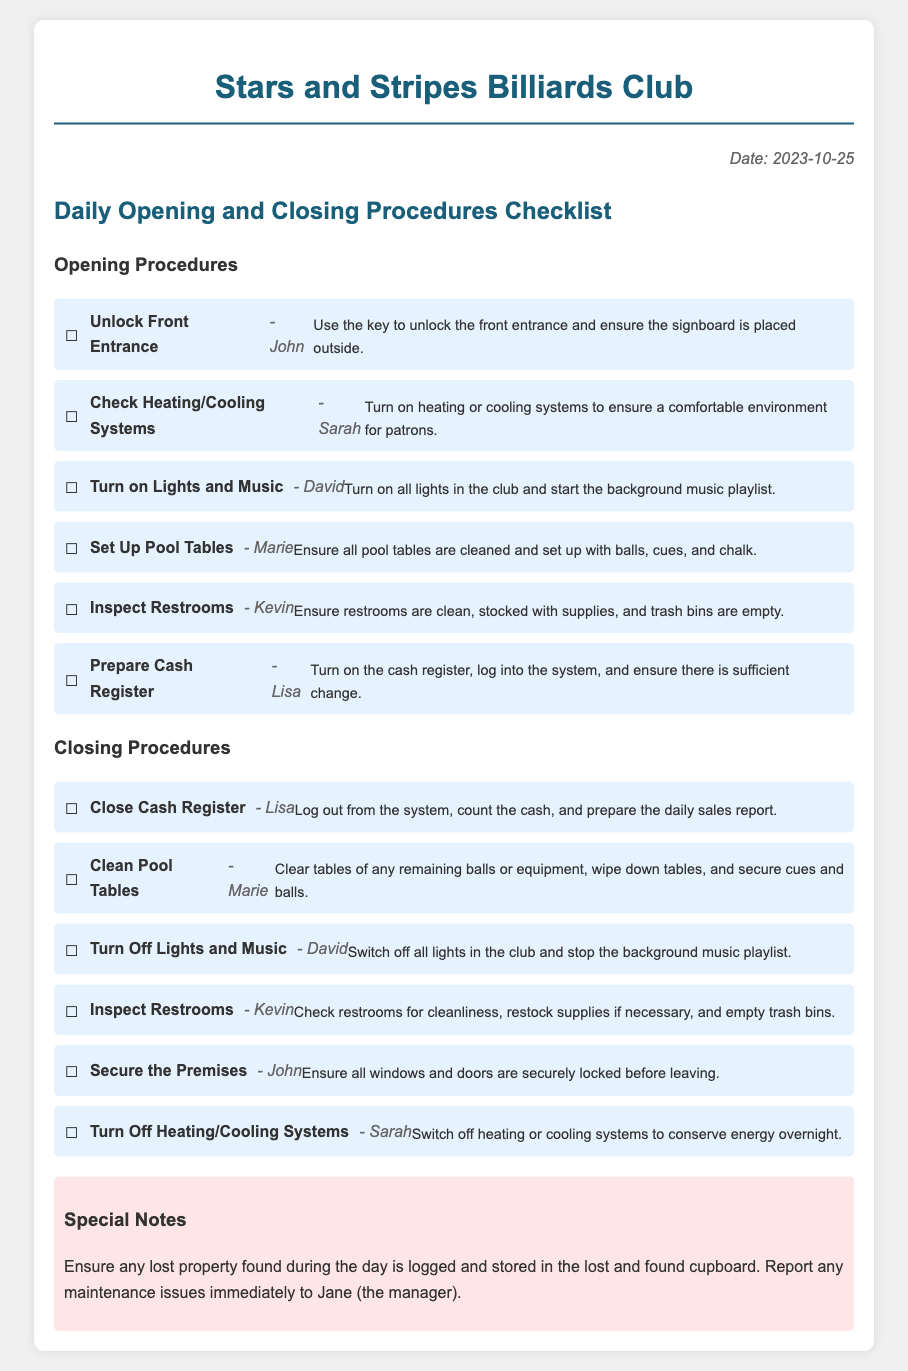What is the date of the checklist? The date is explicitly mentioned at the top of the document.
Answer: 2023-10-25 Who is responsible for setting up the pool tables? The document lists the staff member assigned to each task.
Answer: Marie What task is assigned to Sarah in the opening procedures? Sarah is responsible for checking the heating/cooling systems.
Answer: Check Heating/Cooling Systems How many tasks are listed under closing procedures? The document lists six tasks in the closing procedures section.
Answer: Six What should be done with lost property? The document specifies that lost property found during the day should be logged and stored.
Answer: Logged and stored Which task requires the cash register to be turned off? The task of closing the cash register is related to turning off the cash register.
Answer: Close Cash Register What color is the background of the checklist items? The checklist items have a specific background color mentioned in the style section of the document.
Answer: Light blue (e6f3ff) Who is responsible for inspecting the restrooms at closing? The assigned staff member for this task is identified in the document.
Answer: Kevin 